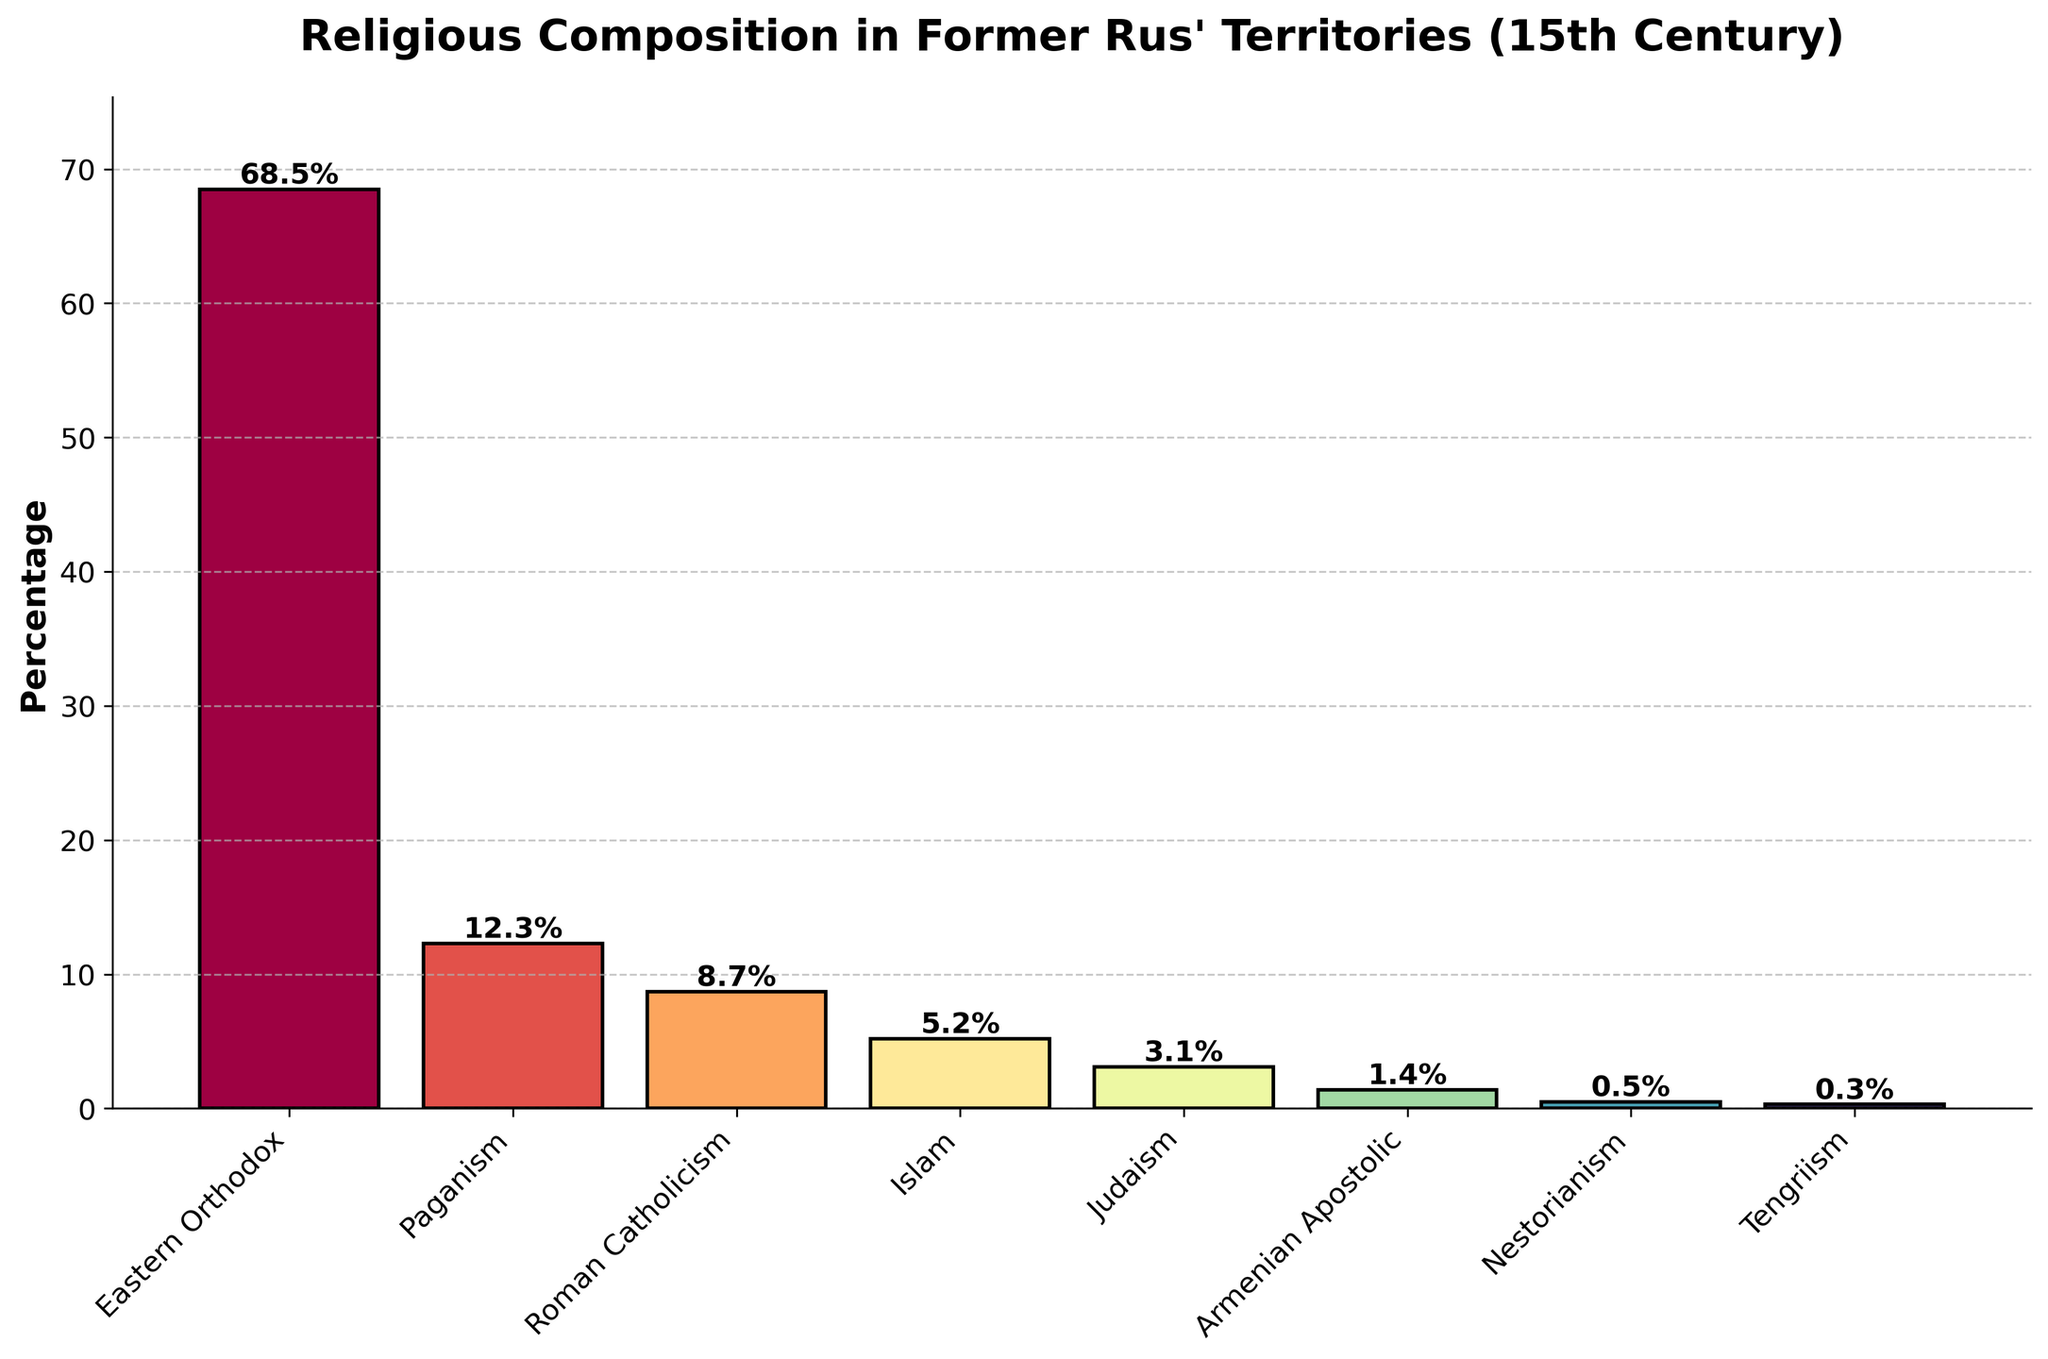Which religion has the highest percentage? The bar representing Eastern Orthodox has the highest height, indicating it has the largest percentage.
Answer: Eastern Orthodox Which religion has the lowest percentage? The bar representing Tengriism has the lowest height, indicating it has the smallest percentage.
Answer: Tengriism What is the combined percentage of Eastern Orthodox and Roman Catholicism? Add the percentages of Eastern Orthodox and Roman Catholicism: 68.5% + 8.7% = 77.2%.
Answer: 77.2% Is the percentage of Paganism more than double that of Islam? The percentage of Paganism is 12.3%, and double the percentage of Islam (5.2%) is 10.4%. Since 12.3% > 10.4%, Paganism is more than double Islam.
Answer: Yes What is the percentage difference between Judaism and Armenian Apostolic? Subtract the percentage of Armenian Apostolic from Judaism: 3.1% - 1.4% = 1.7%.
Answer: 1.7% How does the percentage of Nestorianism compare to that of Tengriism? The bar representing Nestorianism is slightly higher than that of Tengriism. The percentage for Nestorianism is 0.5%, and for Tengriism it is 0.3%, so 0.5% > 0.3%.
Answer: Higher What is the average percentage of the minority religions (Islam, Judaism, Armenian Apostolic, Nestorianism, Tengriism)? Add the percentages of the minority religions and divide by the number: (5.2 + 3.1 + 1.4 + 0.5 + 0.3) / 5 = 10.5 / 5 = 2.1%.
Answer: 2.1% How much higher is the percentage of Eastern Orthodox compared to Roman Catholicism? Subtract the percentage of Roman Catholicism from Eastern Orthodox: 68.5% - 8.7% = 59.8%.
Answer: 59.8% Which religion has a percentage close to one-third of Eastern Orthodox? One-third of Eastern Orthodox is approximately 68.5% / 3 ≈ 22.8%. None of the religions are close to this value, but Paganism at 12.3% is the closest.
Answer: Paganism 